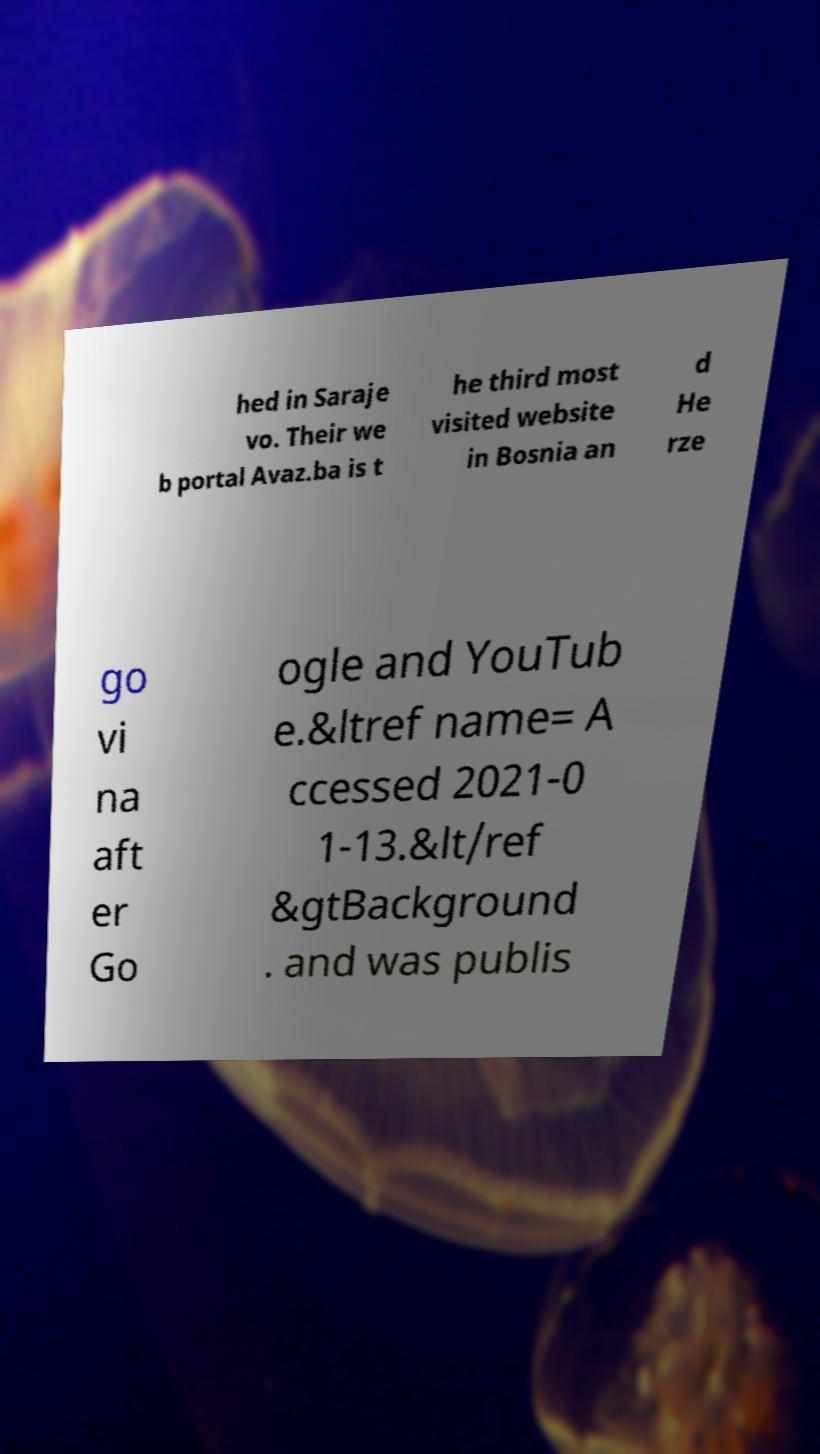I need the written content from this picture converted into text. Can you do that? hed in Saraje vo. Their we b portal Avaz.ba is t he third most visited website in Bosnia an d He rze go vi na aft er Go ogle and YouTub e.&ltref name= A ccessed 2021-0 1-13.&lt/ref &gtBackground . and was publis 